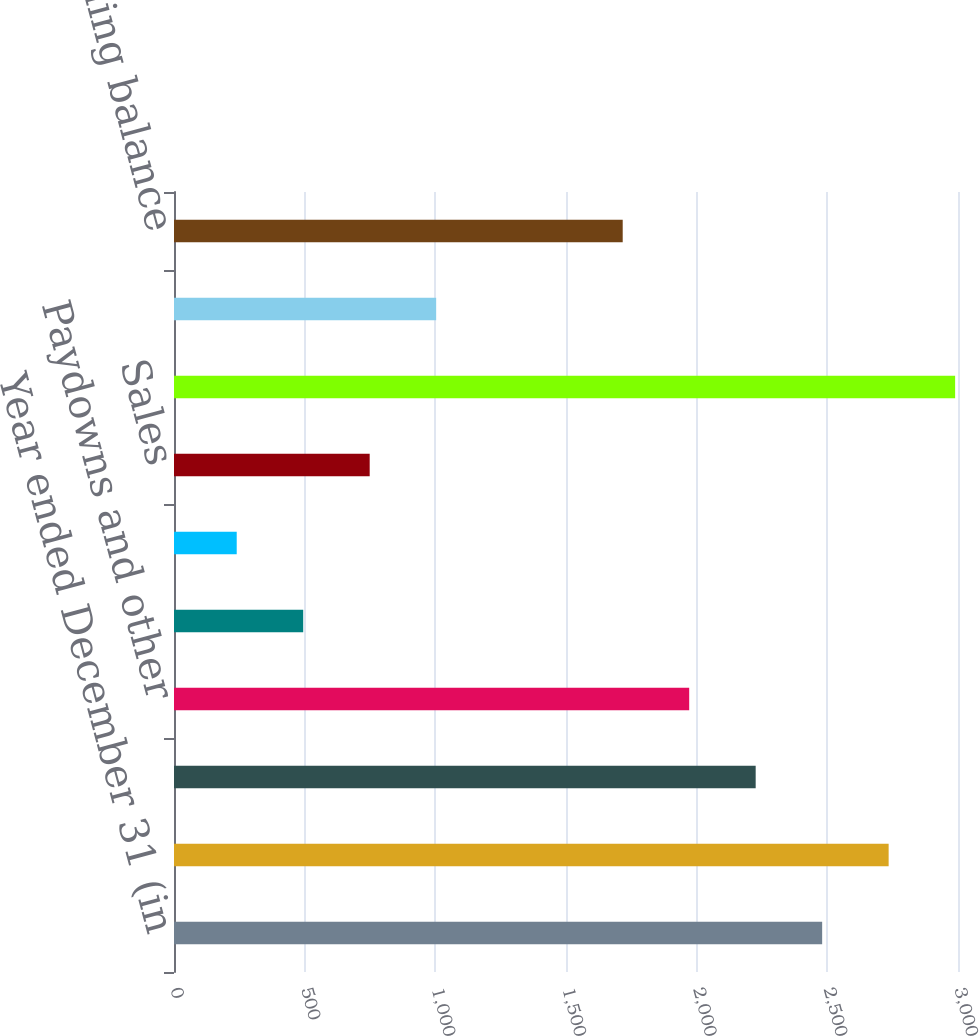Convert chart to OTSL. <chart><loc_0><loc_0><loc_500><loc_500><bar_chart><fcel>Year ended December 31 (in<fcel>Beginning balance<fcel>Additions (a)<fcel>Paydowns and other<fcel>Gross charge-offs<fcel>Returned to performing status<fcel>Sales<fcel>Total reductions<fcel>Net reductions<fcel>Ending balance<nl><fcel>2480.2<fcel>2734.6<fcel>2225.8<fcel>1971.4<fcel>494.4<fcel>240<fcel>748.8<fcel>2989<fcel>1003.2<fcel>1717<nl></chart> 